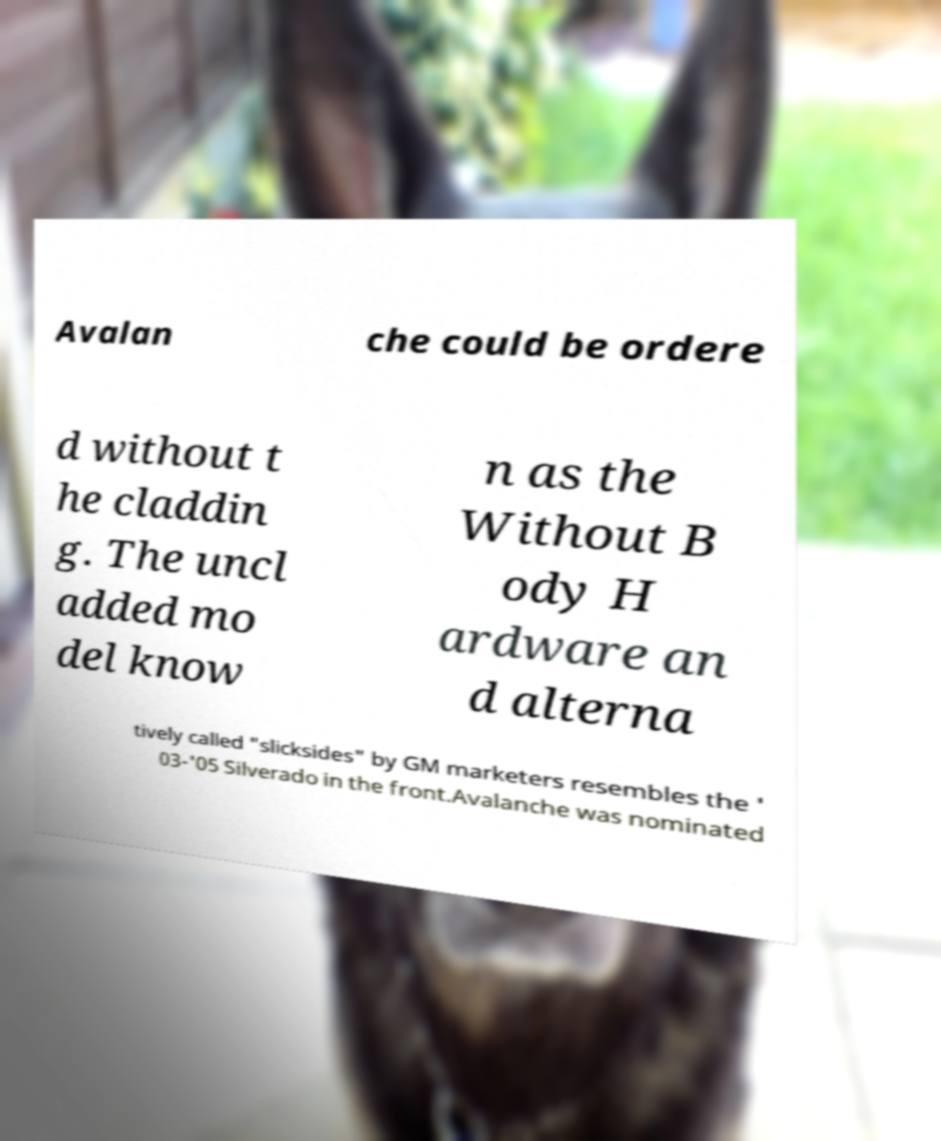For documentation purposes, I need the text within this image transcribed. Could you provide that? Avalan che could be ordere d without t he claddin g. The uncl added mo del know n as the Without B ody H ardware an d alterna tively called "slicksides" by GM marketers resembles the ' 03-'05 Silverado in the front.Avalanche was nominated 